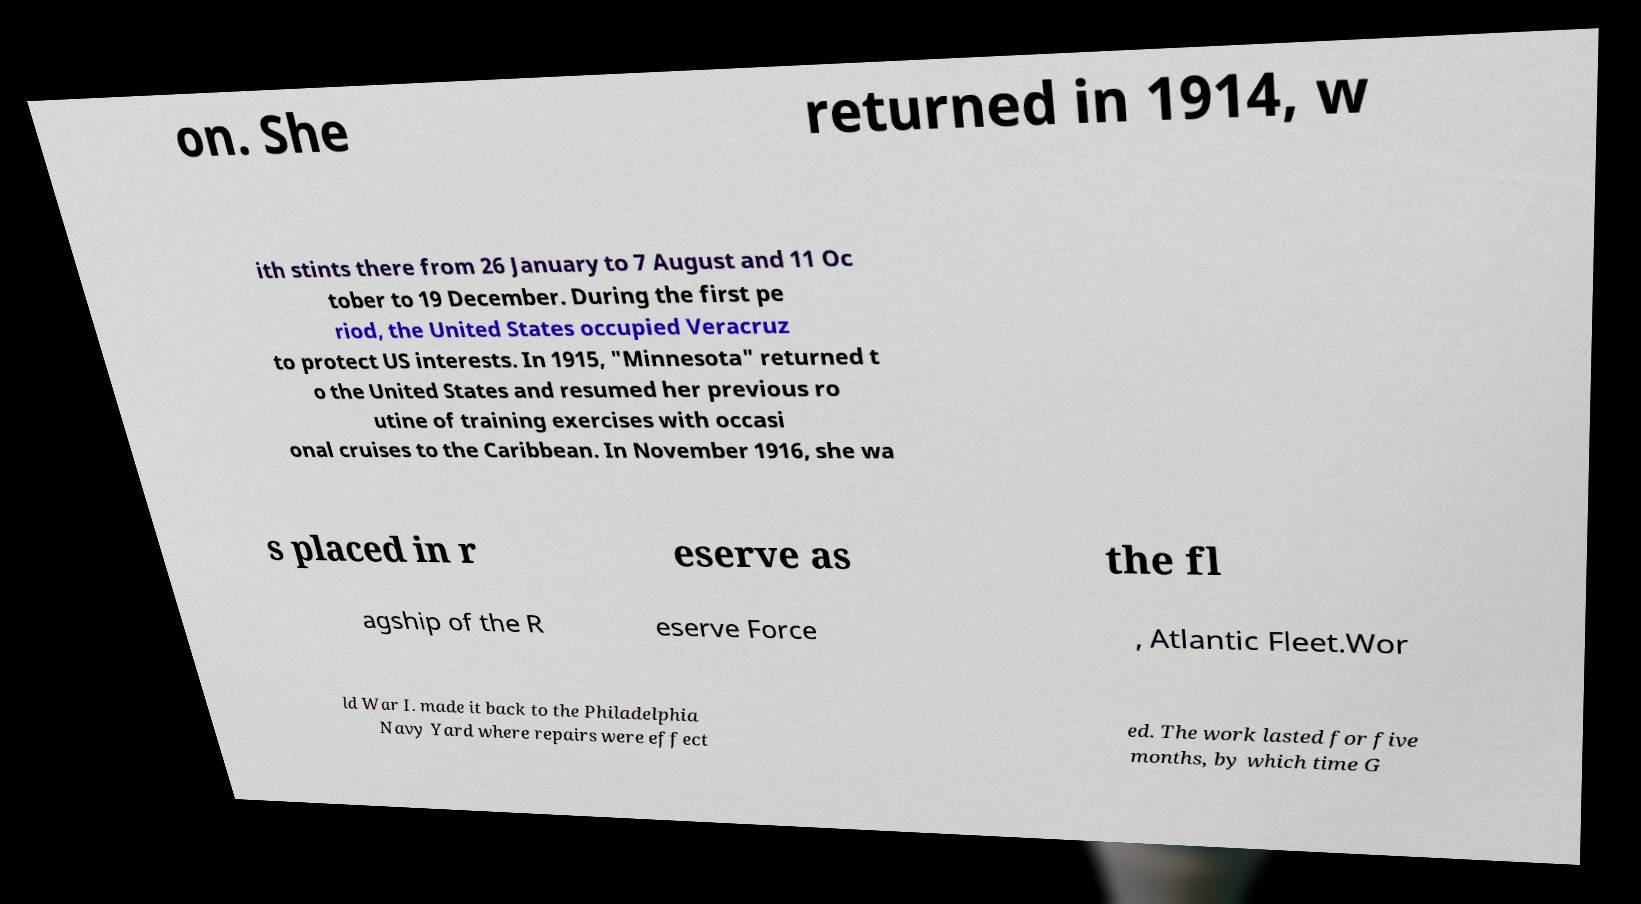Please identify and transcribe the text found in this image. on. She returned in 1914, w ith stints there from 26 January to 7 August and 11 Oc tober to 19 December. During the first pe riod, the United States occupied Veracruz to protect US interests. In 1915, "Minnesota" returned t o the United States and resumed her previous ro utine of training exercises with occasi onal cruises to the Caribbean. In November 1916, she wa s placed in r eserve as the fl agship of the R eserve Force , Atlantic Fleet.Wor ld War I. made it back to the Philadelphia Navy Yard where repairs were effect ed. The work lasted for five months, by which time G 